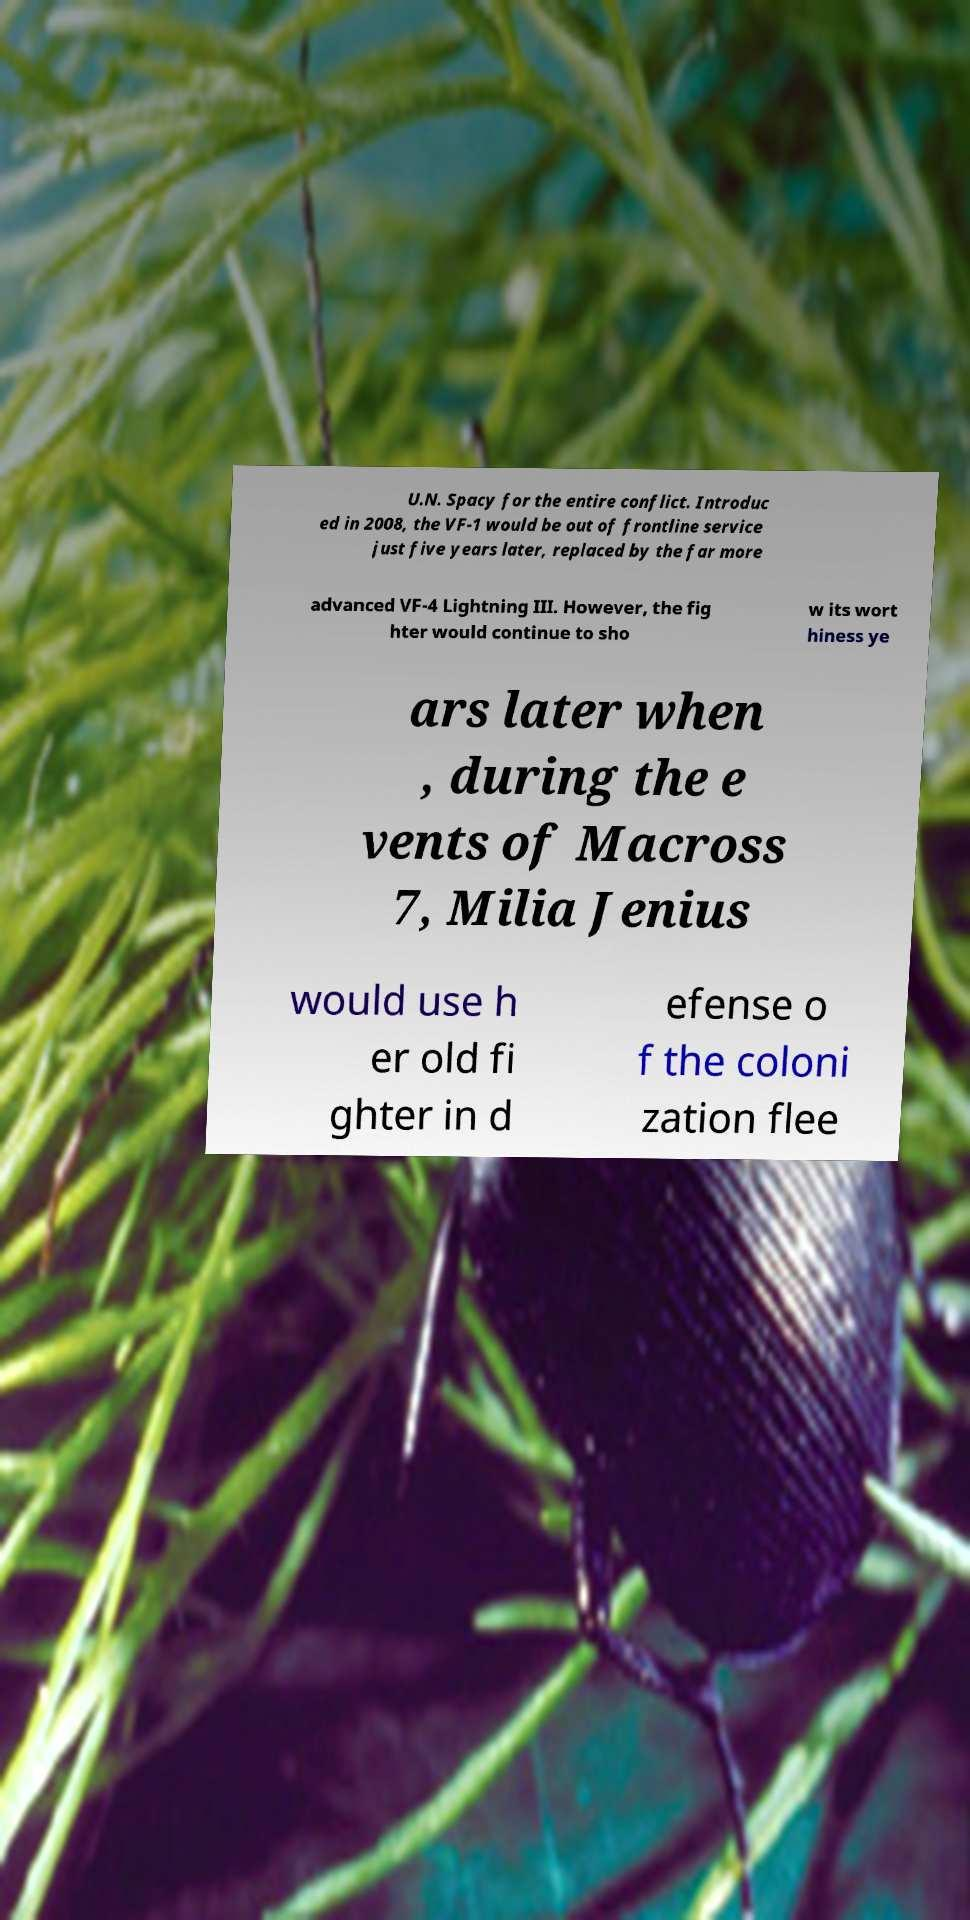Could you assist in decoding the text presented in this image and type it out clearly? U.N. Spacy for the entire conflict. Introduc ed in 2008, the VF-1 would be out of frontline service just five years later, replaced by the far more advanced VF-4 Lightning III. However, the fig hter would continue to sho w its wort hiness ye ars later when , during the e vents of Macross 7, Milia Jenius would use h er old fi ghter in d efense o f the coloni zation flee 